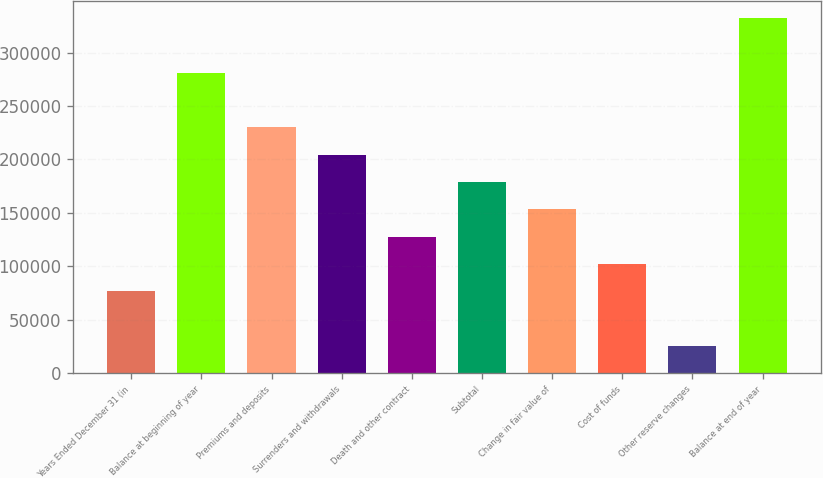Convert chart to OTSL. <chart><loc_0><loc_0><loc_500><loc_500><bar_chart><fcel>Years Ended December 31 (in<fcel>Balance at beginning of year<fcel>Premiums and deposits<fcel>Surrenders and withdrawals<fcel>Death and other contract<fcel>Subtotal<fcel>Change in fair value of<fcel>Cost of funds<fcel>Other reserve changes<fcel>Balance at end of year<nl><fcel>76648.8<fcel>281022<fcel>229928<fcel>204382<fcel>127742<fcel>178835<fcel>153289<fcel>102195<fcel>25555.6<fcel>332115<nl></chart> 